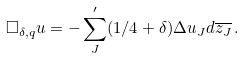<formula> <loc_0><loc_0><loc_500><loc_500>\Box _ { \delta , q } u = - \sum ^ { \prime } _ { J } ( 1 / 4 + \delta ) \Delta u _ { J } d \overline { z _ { J } } \, .</formula> 